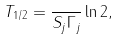<formula> <loc_0><loc_0><loc_500><loc_500>T _ { 1 / 2 } = \frac { } { S _ { j } \Gamma _ { j } } \ln 2 ,</formula> 